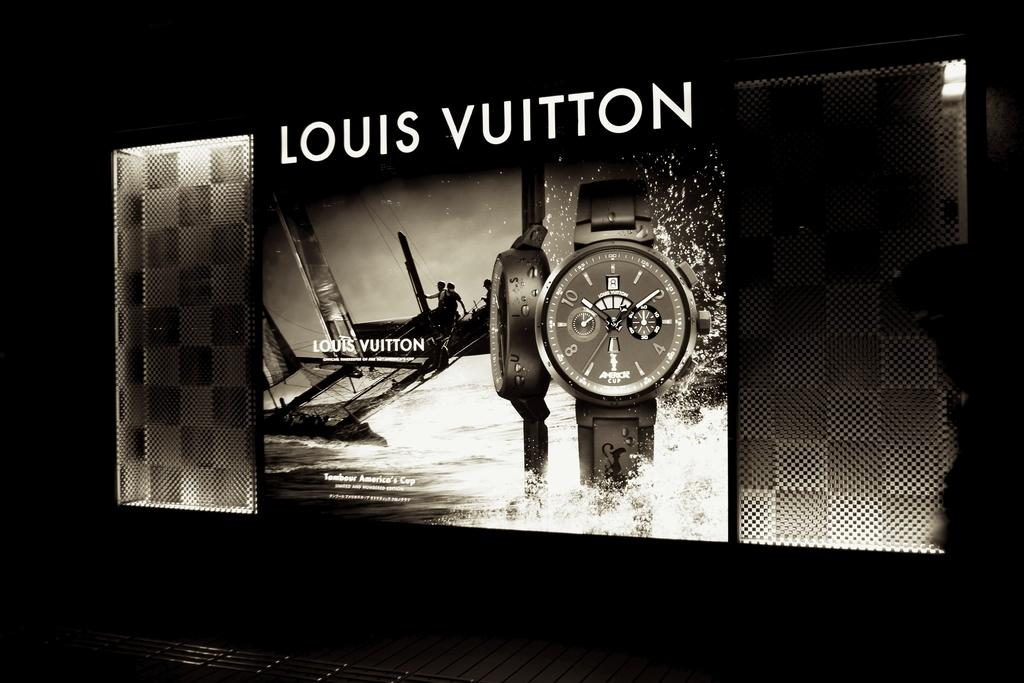<image>
Offer a succinct explanation of the picture presented. A black and white ad of a Vuitton watch. 